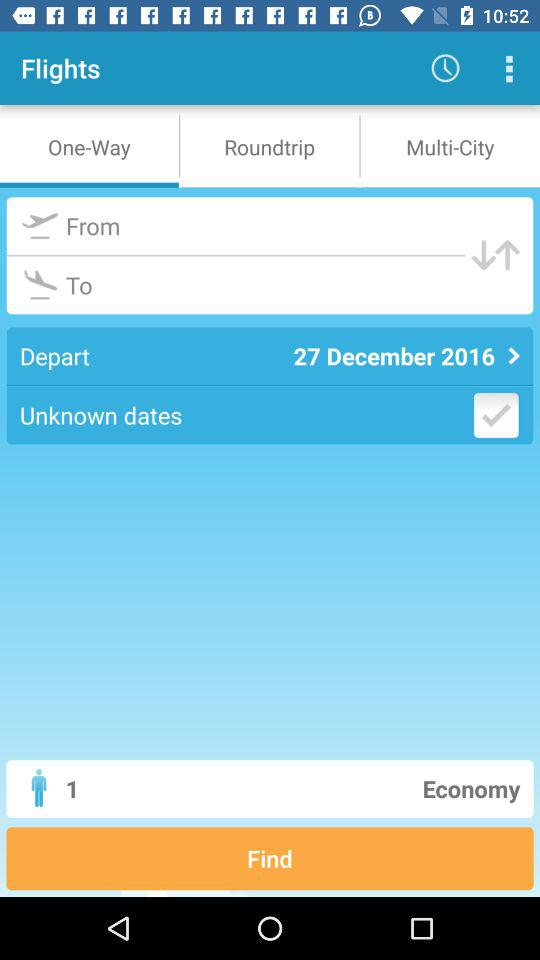Where is the flight going?
When the provided information is insufficient, respond with <no answer>. <no answer> 